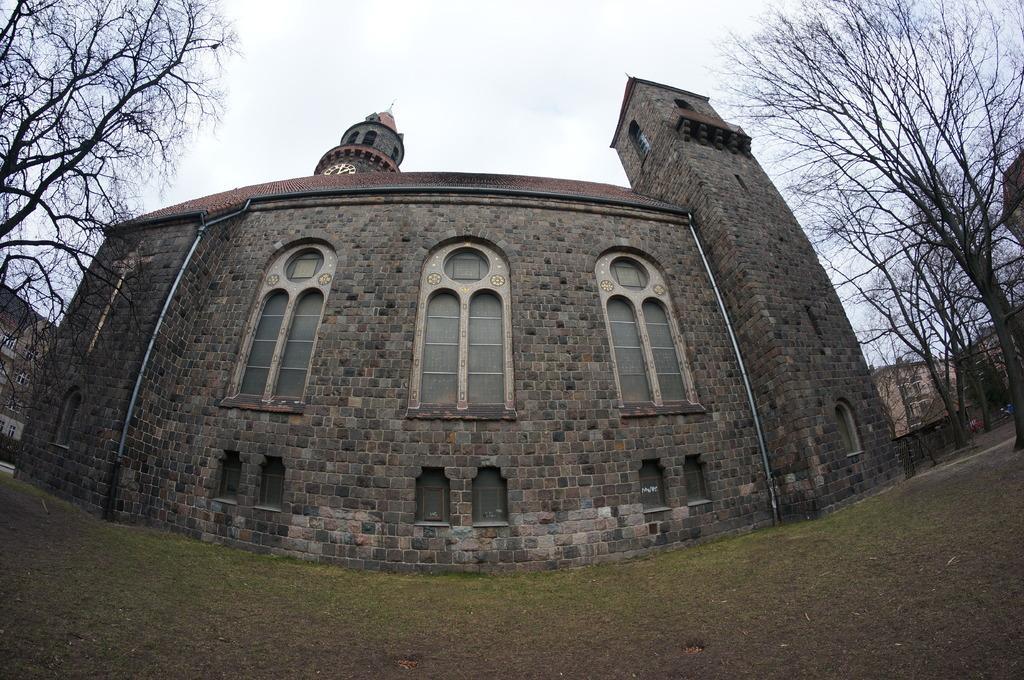Could you give a brief overview of what you see in this image? In this image I can see the ground, some grass on the ground, few trees and a building. I can see few windows of the building and in the background I can see the sky. 